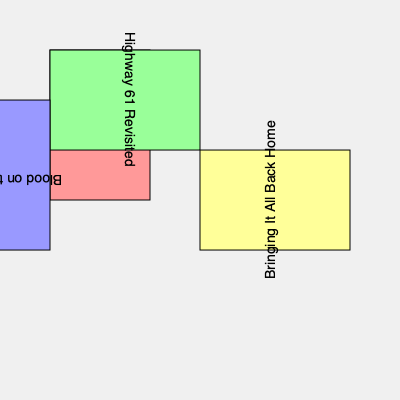If you were to rotate and align all the Dylan concert posters so that their titles are readable from left to right, how many degrees clockwise would you need to rotate the "Bringing It All Back Home" poster? To solve this problem, let's follow these steps:

1. Observe the current orientation of each poster:
   - "Blonde on Blonde" is already correctly oriented (0°)
   - "Highway 61 Revisited" is rotated 90° counterclockwise
   - "Blood on the Tracks" is upside down (180°)
   - "Bringing It All Back Home" is rotated 270° counterclockwise (or 90° clockwise)

2. To make all posters readable from left to right, we need to rotate them to the 0° position.

3. Focus on the "Bringing It All Back Home" poster:
   - It is currently at 270° counterclockwise
   - To reach 0°, we need to rotate it 90° clockwise

4. The question asks for the clockwise rotation, so our answer is already in the correct direction.

Therefore, the "Bringing It All Back Home" poster needs to be rotated 90° clockwise to align with the others.
Answer: 90° 